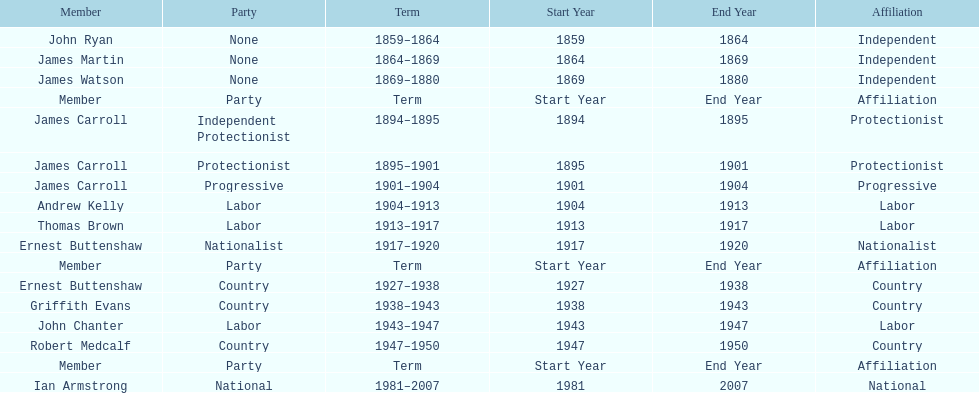Which member of the second incarnation of the lachlan was also a nationalist? Ernest Buttenshaw. 